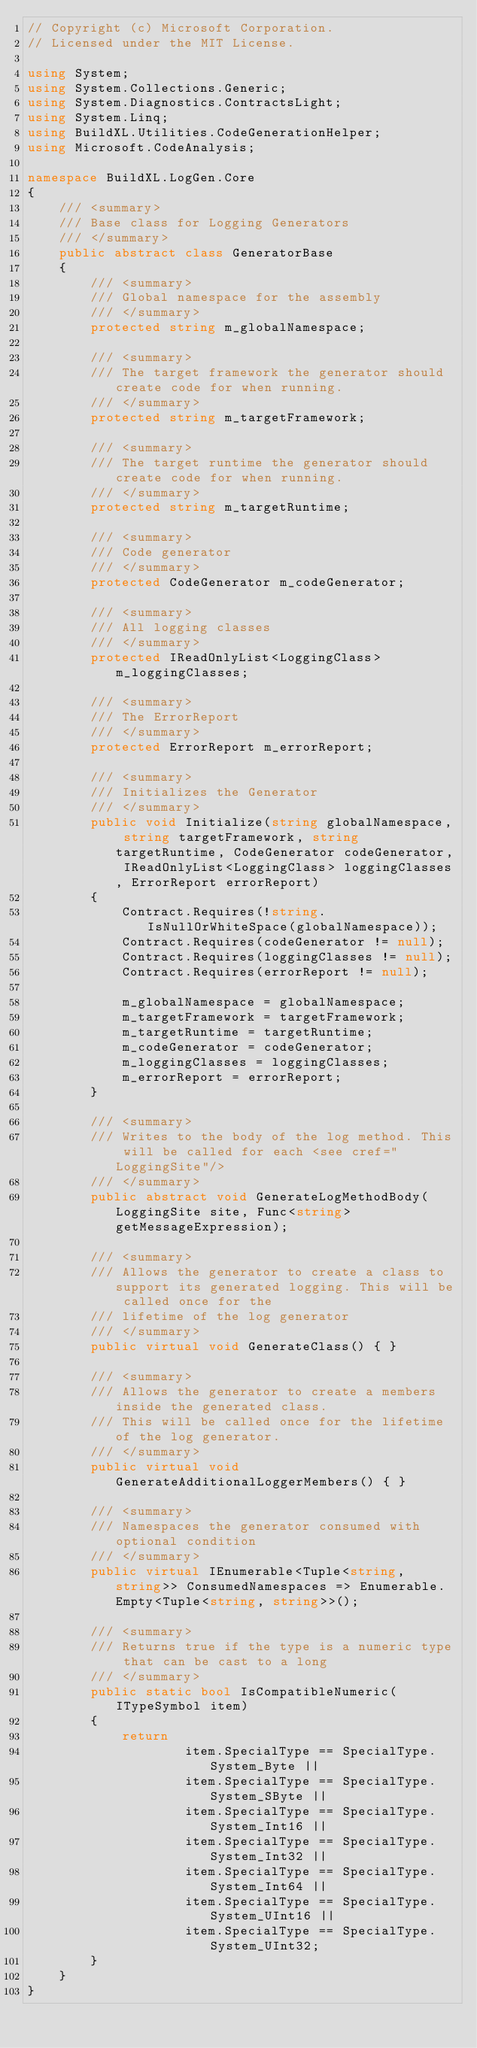<code> <loc_0><loc_0><loc_500><loc_500><_C#_>// Copyright (c) Microsoft Corporation.
// Licensed under the MIT License.

using System;
using System.Collections.Generic;
using System.Diagnostics.ContractsLight;
using System.Linq;
using BuildXL.Utilities.CodeGenerationHelper;
using Microsoft.CodeAnalysis;

namespace BuildXL.LogGen.Core
{
    /// <summary>
    /// Base class for Logging Generators
    /// </summary>
    public abstract class GeneratorBase
    {
        /// <summary>
        /// Global namespace for the assembly
        /// </summary>
        protected string m_globalNamespace;

        /// <summary>
        /// The target framework the generator should create code for when running.
        /// </summary>
        protected string m_targetFramework;

        /// <summary>
        /// The target runtime the generator should create code for when running.
        /// </summary>
        protected string m_targetRuntime;

        /// <summary>
        /// Code generator
        /// </summary>
        protected CodeGenerator m_codeGenerator;

        /// <summary>
        /// All logging classes
        /// </summary>
        protected IReadOnlyList<LoggingClass> m_loggingClasses;

        /// <summary>
        /// The ErrorReport
        /// </summary>
        protected ErrorReport m_errorReport;

        /// <summary>
        /// Initializes the Generator
        /// </summary>
        public void Initialize(string globalNamespace, string targetFramework, string targetRuntime, CodeGenerator codeGenerator, IReadOnlyList<LoggingClass> loggingClasses, ErrorReport errorReport)
        {
            Contract.Requires(!string.IsNullOrWhiteSpace(globalNamespace));
            Contract.Requires(codeGenerator != null);
            Contract.Requires(loggingClasses != null);
            Contract.Requires(errorReport != null);

            m_globalNamespace = globalNamespace;
            m_targetFramework = targetFramework;
            m_targetRuntime = targetRuntime;
            m_codeGenerator = codeGenerator;
            m_loggingClasses = loggingClasses;
            m_errorReport = errorReport;
        }

        /// <summary>
        /// Writes to the body of the log method. This will be called for each <see cref="LoggingSite"/>
        /// </summary>
        public abstract void GenerateLogMethodBody(LoggingSite site, Func<string> getMessageExpression);

        /// <summary>
        /// Allows the generator to create a class to support its generated logging. This will be called once for the
        /// lifetime of the log generator
        /// </summary>
        public virtual void GenerateClass() { }

        /// <summary>
        /// Allows the generator to create a members inside the generated class.
        /// This will be called once for the lifetime of the log generator.
        /// </summary>
        public virtual void GenerateAdditionalLoggerMembers() { }

        /// <summary>
        /// Namespaces the generator consumed with optional condition
        /// </summary>
        public virtual IEnumerable<Tuple<string, string>> ConsumedNamespaces => Enumerable.Empty<Tuple<string, string>>();

        /// <summary>
        /// Returns true if the type is a numeric type that can be cast to a long
        /// </summary>
        public static bool IsCompatibleNumeric(ITypeSymbol item)
        {
            return
                    item.SpecialType == SpecialType.System_Byte ||
                    item.SpecialType == SpecialType.System_SByte ||
                    item.SpecialType == SpecialType.System_Int16 ||
                    item.SpecialType == SpecialType.System_Int32 ||
                    item.SpecialType == SpecialType.System_Int64 ||
                    item.SpecialType == SpecialType.System_UInt16 ||
                    item.SpecialType == SpecialType.System_UInt32;
        }
    }
}
</code> 